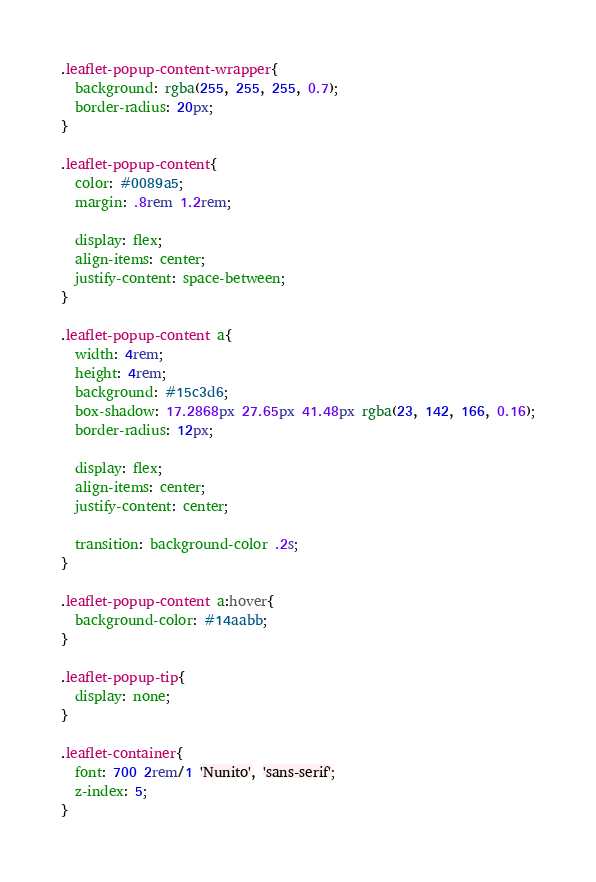Convert code to text. <code><loc_0><loc_0><loc_500><loc_500><_CSS_>
.leaflet-popup-content-wrapper{
  background: rgba(255, 255, 255, 0.7);
  border-radius: 20px;
}

.leaflet-popup-content{
  color: #0089a5;
  margin: .8rem 1.2rem;

  display: flex;
  align-items: center;
  justify-content: space-between;
}

.leaflet-popup-content a{
  width: 4rem;
  height: 4rem;
  background: #15c3d6;
  box-shadow: 17.2868px 27.65px 41.48px rgba(23, 142, 166, 0.16);
  border-radius: 12px;

  display: flex;
  align-items: center;
  justify-content: center;

  transition: background-color .2s;
}

.leaflet-popup-content a:hover{
  background-color: #14aabb;
}

.leaflet-popup-tip{
  display: none;
}

.leaflet-container{
  font: 700 2rem/1 'Nunito', 'sans-serif';
  z-index: 5;
}
</code> 